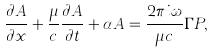Convert formula to latex. <formula><loc_0><loc_0><loc_500><loc_500>\frac { \partial A } { \partial x } + \frac { \mu } { c } \frac { \partial A } { \partial t } + \alpha A = \frac { 2 \pi i \omega } { \mu c } \Gamma P ,</formula> 